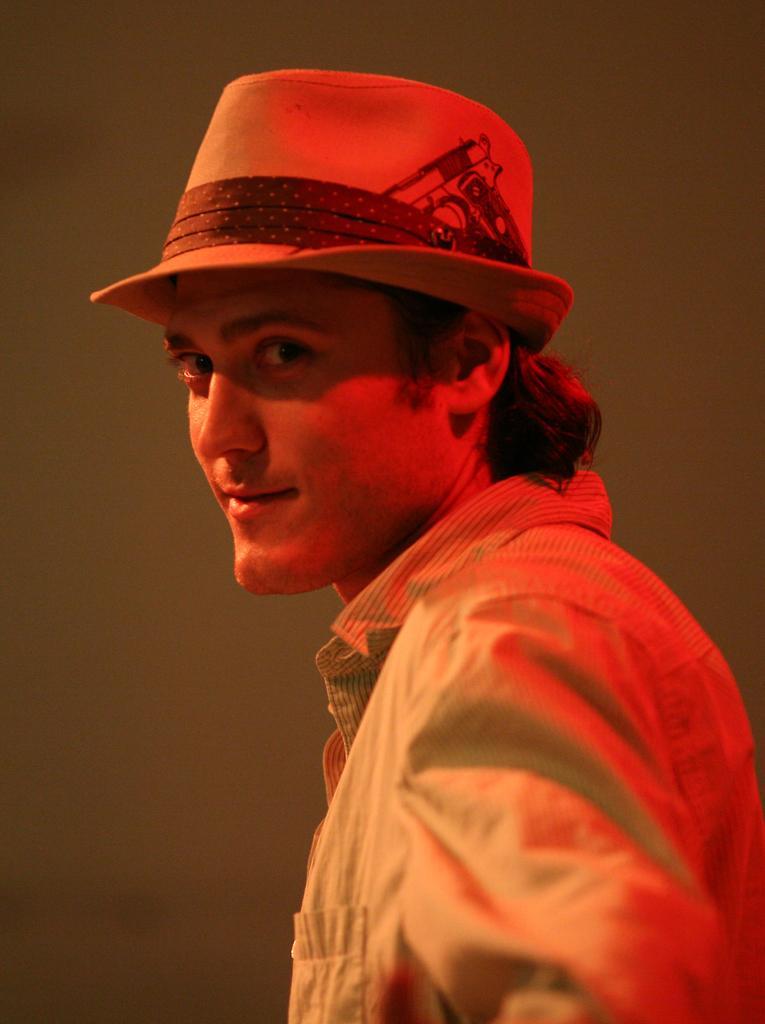Can you describe this image briefly? In this picture there is a man who is wearing hat and shirt. In the back I can see the wall. 